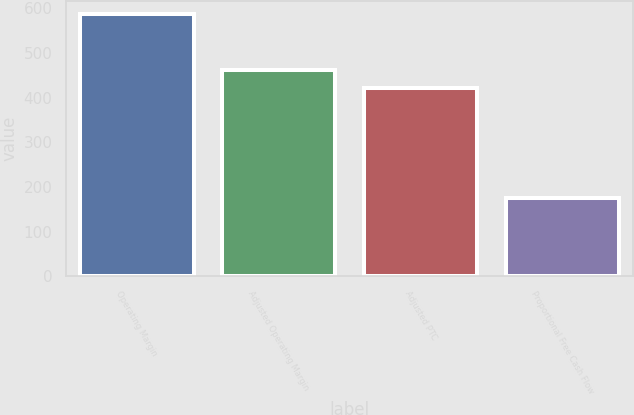Convert chart. <chart><loc_0><loc_0><loc_500><loc_500><bar_chart><fcel>Operating Margin<fcel>Adjusted Operating Margin<fcel>Adjusted PTC<fcel>Proportional Free Cash Flow<nl><fcel>587<fcel>462.1<fcel>421<fcel>176<nl></chart> 